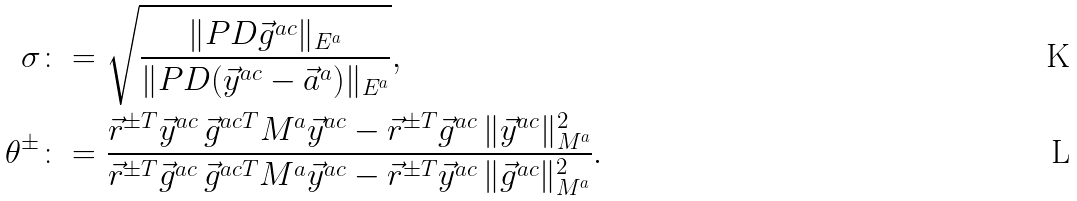<formula> <loc_0><loc_0><loc_500><loc_500>\sigma & \colon = \sqrt { \frac { \| P D \vec { g } ^ { a c } \| _ { E ^ { a } } } { \| P D ( \vec { y } ^ { a c } - \vec { a } ^ { a } ) \| _ { E ^ { a } } } } , \\ \theta ^ { \pm } & \colon = \frac { \vec { r } ^ { \pm T } \vec { y } ^ { a c } \, \vec { g } ^ { a c T } M ^ { a } \vec { y } ^ { a c } - \vec { r } ^ { \pm T } \vec { g } ^ { a c } \, \| \vec { y } ^ { a c } \| _ { M ^ { a } } ^ { 2 } } { \vec { r } ^ { \pm T } \vec { g } ^ { a c } \, \vec { g } ^ { a c T } M ^ { a } \vec { y } ^ { a c } - \vec { r } ^ { \pm T } \vec { y } ^ { a c } \, \| \vec { g } ^ { a c } \| _ { M ^ { a } } ^ { 2 } } .</formula> 